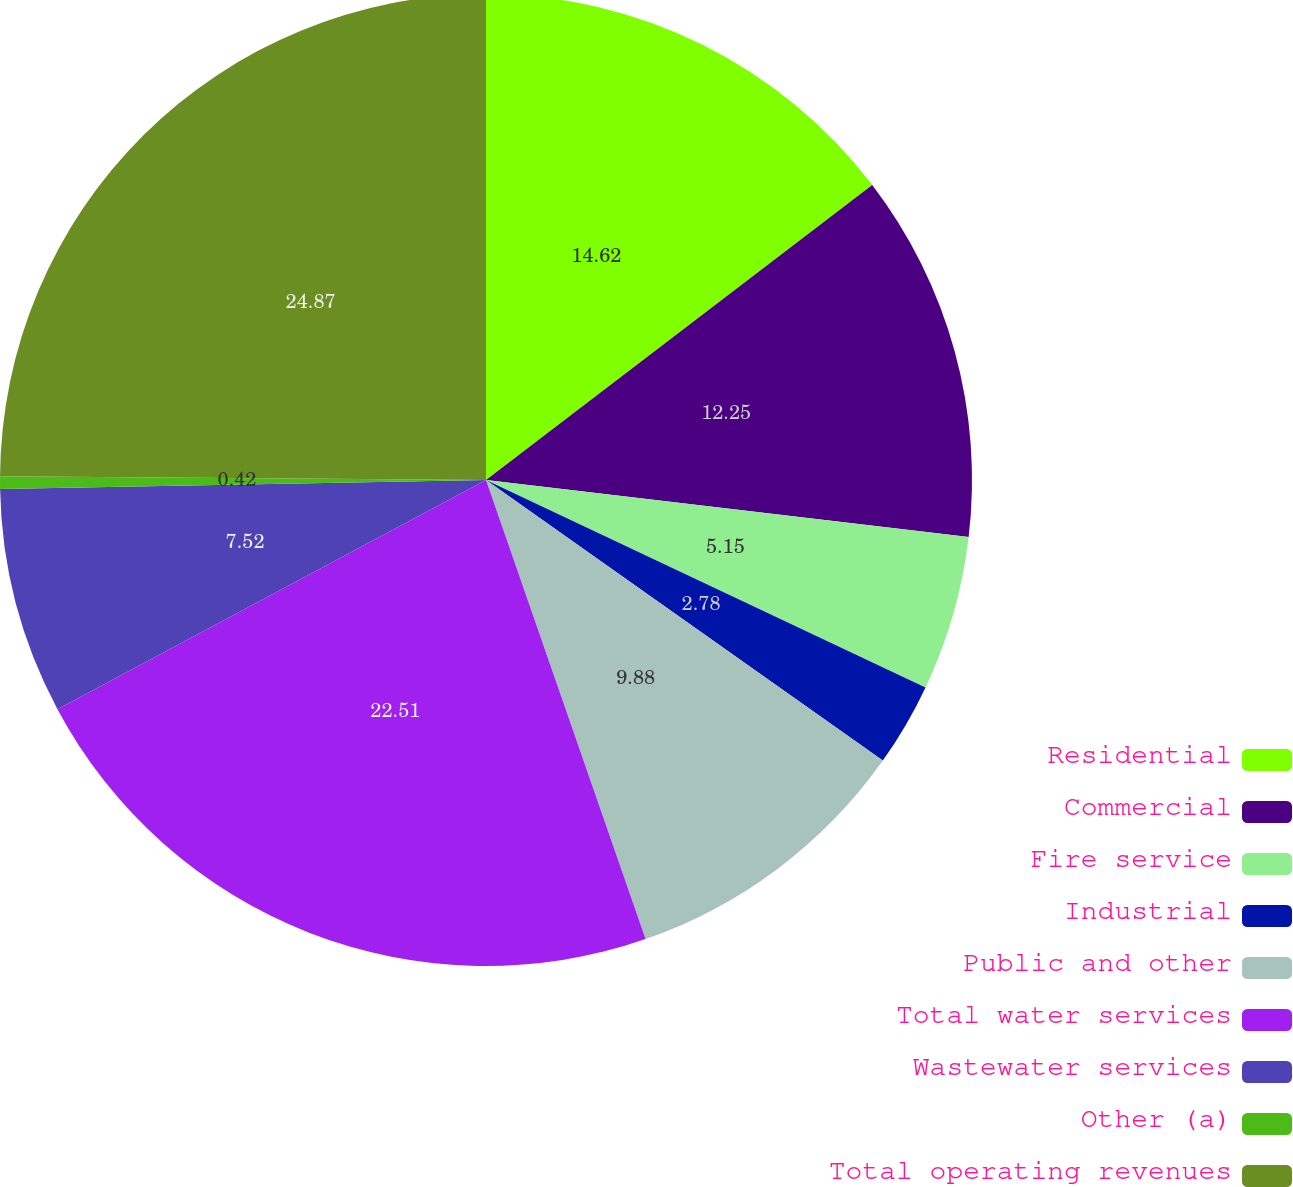Convert chart to OTSL. <chart><loc_0><loc_0><loc_500><loc_500><pie_chart><fcel>Residential<fcel>Commercial<fcel>Fire service<fcel>Industrial<fcel>Public and other<fcel>Total water services<fcel>Wastewater services<fcel>Other (a)<fcel>Total operating revenues<nl><fcel>14.62%<fcel>12.25%<fcel>5.15%<fcel>2.78%<fcel>9.88%<fcel>22.51%<fcel>7.52%<fcel>0.42%<fcel>24.88%<nl></chart> 